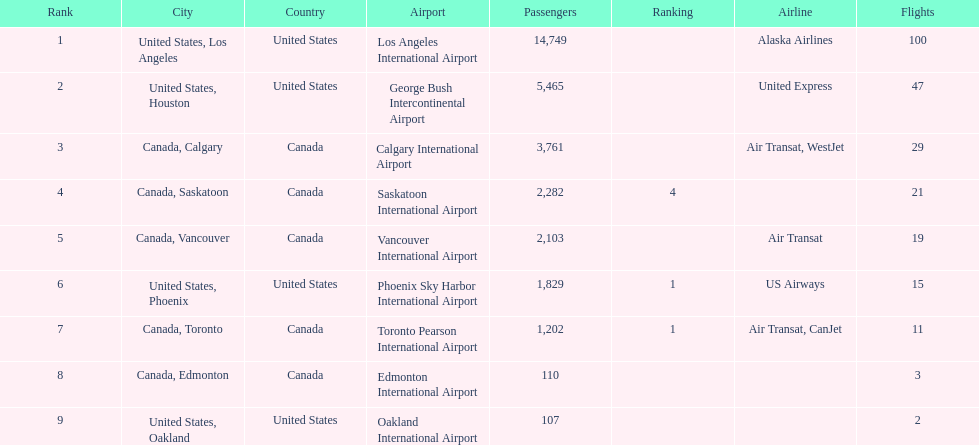Parse the full table. {'header': ['Rank', 'City', 'Country', 'Airport', 'Passengers', 'Ranking', 'Airline', 'Flights'], 'rows': [['1', 'United States, Los Angeles', 'United States', 'Los Angeles International Airport', '14,749', '', 'Alaska Airlines', '100'], ['2', 'United States, Houston', 'United States', 'George Bush Intercontinental Airport', '5,465', '', 'United Express', '47'], ['3', 'Canada, Calgary', 'Canada', 'Calgary International Airport', '3,761', '', 'Air Transat, WestJet', '29'], ['4', 'Canada, Saskatoon', 'Canada', 'Saskatoon International Airport', '2,282', '4', '', '21'], ['5', 'Canada, Vancouver', 'Canada', 'Vancouver International Airport', '2,103', '', 'Air Transat', '19'], ['6', 'United States, Phoenix', 'United States', 'Phoenix Sky Harbor International Airport', '1,829', '1', 'US Airways', '15'], ['7', 'Canada, Toronto', 'Canada', 'Toronto Pearson International Airport', '1,202', '1', 'Air Transat, CanJet', '11'], ['8', 'Canada, Edmonton', 'Canada', 'Edmonton International Airport', '110', '', '', '3'], ['9', 'United States, Oakland', 'United States', 'Oakland International Airport', '107', '', '', '2']]} What is the average number of passengers in the united states? 5537.5. 